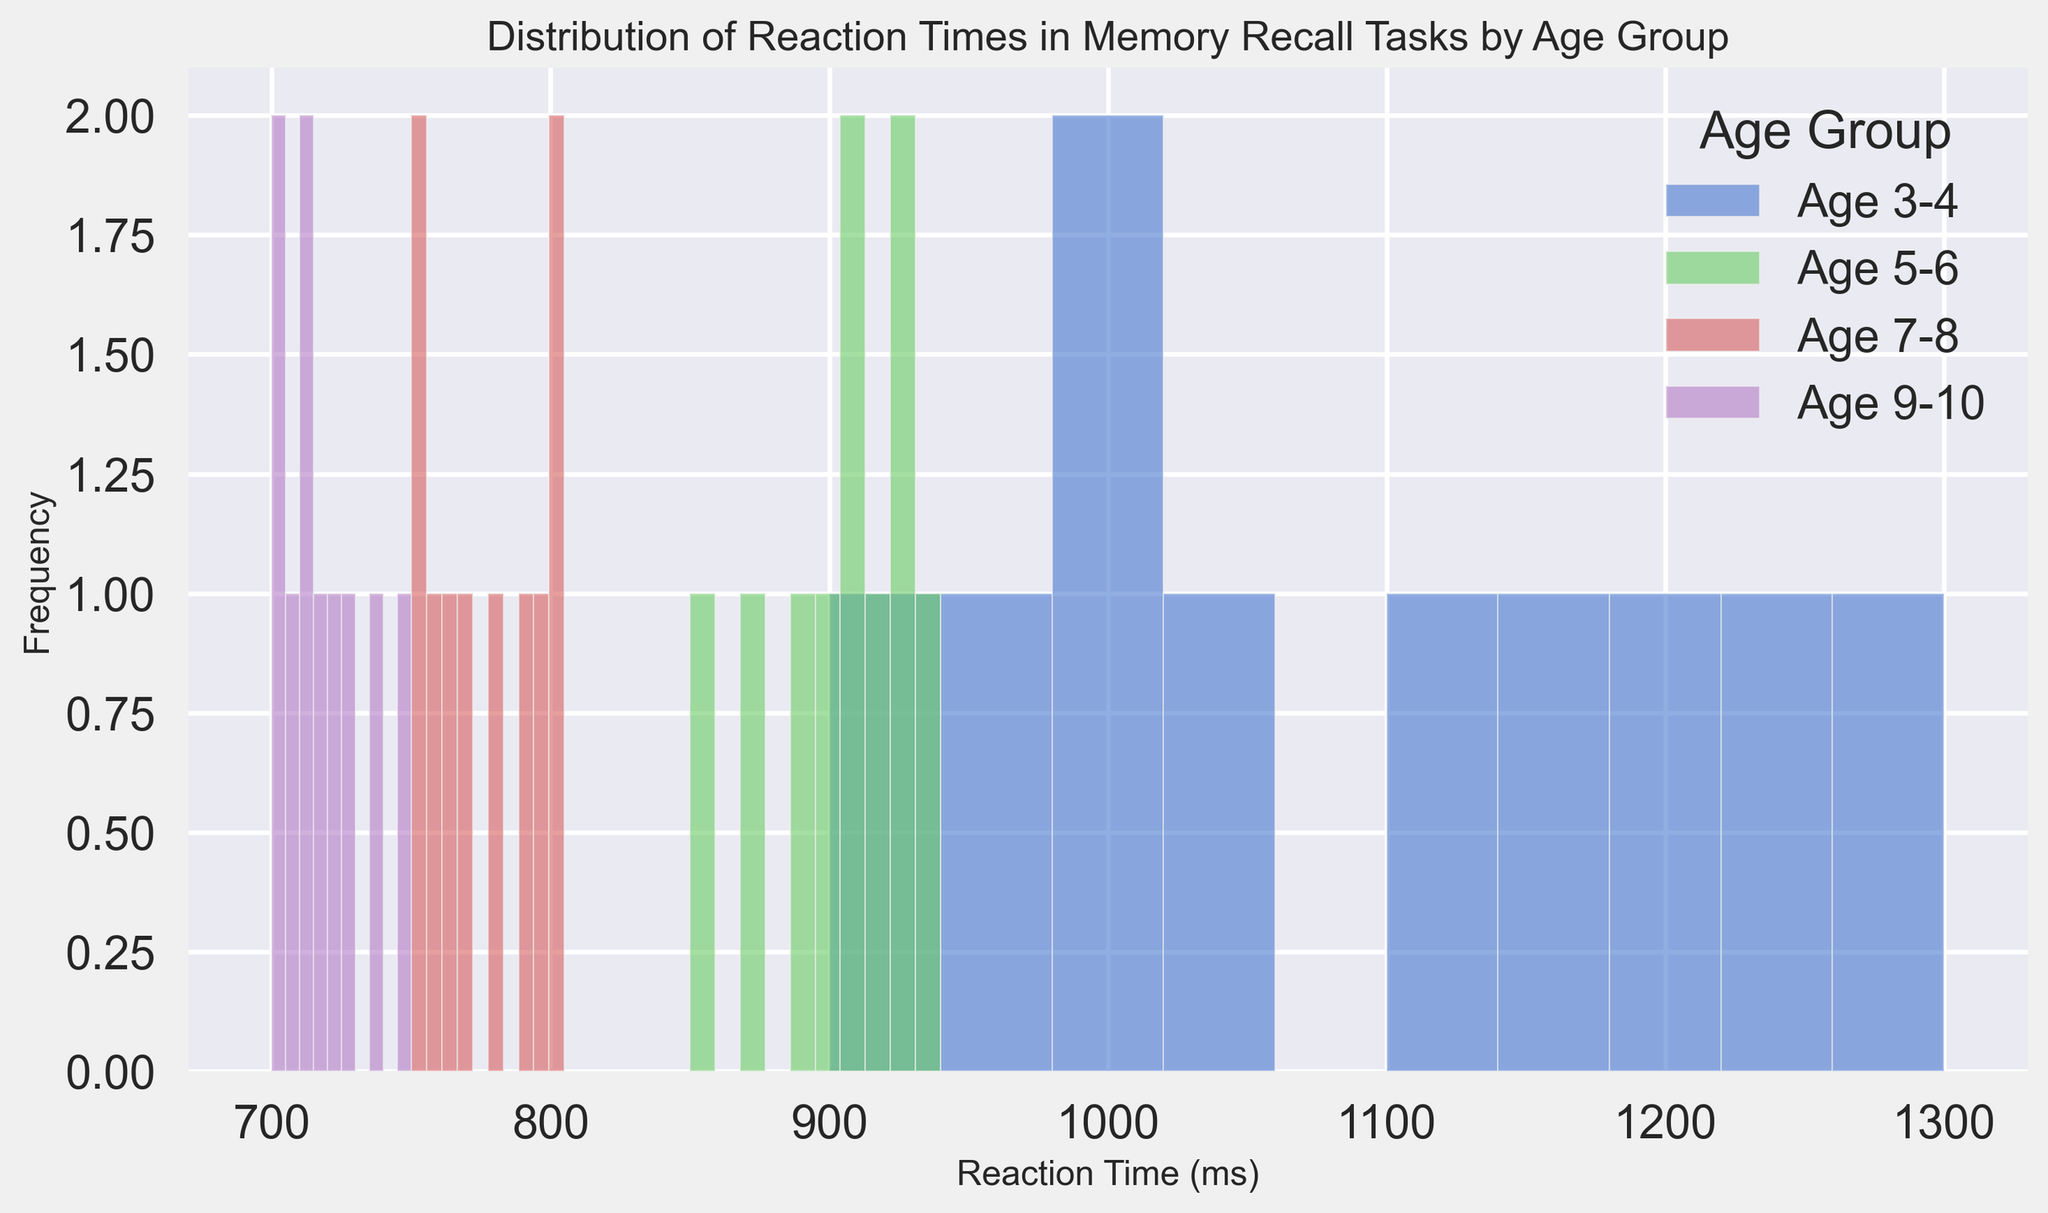What age group has the highest reaction time? The 3-4 age group has the highest reaction time, as their histogram bars are positioned towards the right (higher reaction times) compared to the other age groups.
Answer: 3-4 Compare the distribution of reaction times between the 5-6 and 7-8 age groups. Which group has shorter reaction times? The 7-8 age group's histogram bars are positioned more to the left (shorter reaction times) compared to the 5-6 age group.
Answer: 7-8 Which age group shows the most variability in reaction times based on the histogram? The 3-4 age group shows the most variability, indicated by a wider spread in their histogram bars.
Answer: 3-4 Compare the peak frequencies of the 7-8 and 9-10 age groups. Which one has a higher peak frequency? The 9-10 age group has a higher peak frequency as their histogram bars are taller than those of the 7-8 age group.
Answer: 9-10 What is the approximate range of reaction times for the 5-6 age group? For the 5-6 age group, the histogram bars range from about 850 ms to 940 ms.
Answer: Approximately 850 ms to 940 ms Estimate the most frequent reaction time range for the 3-4 age group. The most frequent reaction time range for the 3-4 age group appears to be between 1050 ms and 1150 ms based on the height of the histogram bars.
Answer: 1050 ms to 1150 ms Compare the overlap of reaction times for the 7-8 and 9-10 age groups. Do they significantly overlap? The reaction times for the 7-8 age group (750 ms to 805 ms) primarily do not overlap significantly with the 9-10 age group (700 ms to 750 ms) except at the highest reaction times of 750 ms.
Answer: No significant overlap Is there any age group that has a reaction time below 800 ms? Yes, the 7-8 and 9-10 age groups both have reaction times below 800 ms.
Answer: Yes Which age group seems to have the least variability in reaction times based on the histogram? The 9-10 age group shows the least variability, indicated by a narrower spread in their histogram bars.
Answer: 9-10 What is the general trend of reaction times across the age groups? Generally, reaction times decrease as age increases, shown by the histograms shifting left as age increases.
Answer: Decreasing 